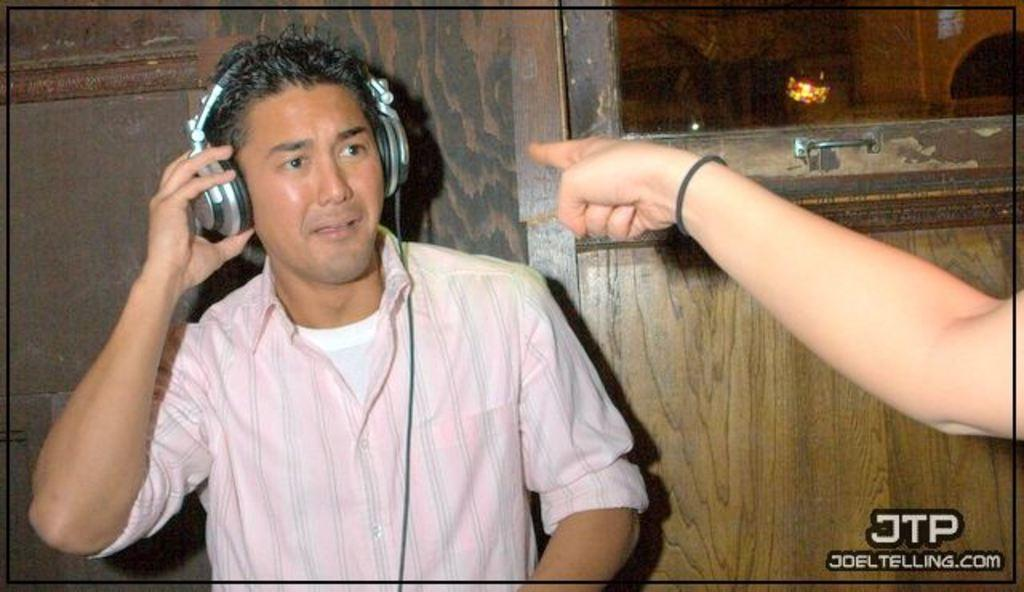What can be seen in the image? There is a person in the image. What is the person wearing? The person is wearing headphones. Can you describe the hand of another person visible in the image? Yes, there is a hand of a person visible on the right side of the image. What is visible in the background of the image? There is a door, a light, and a wall in the background of the image. What type of science experiment is being conducted in the image? There is no science experiment present in the image. Can you see any bubbles in the image? There are no bubbles visible in the image. 